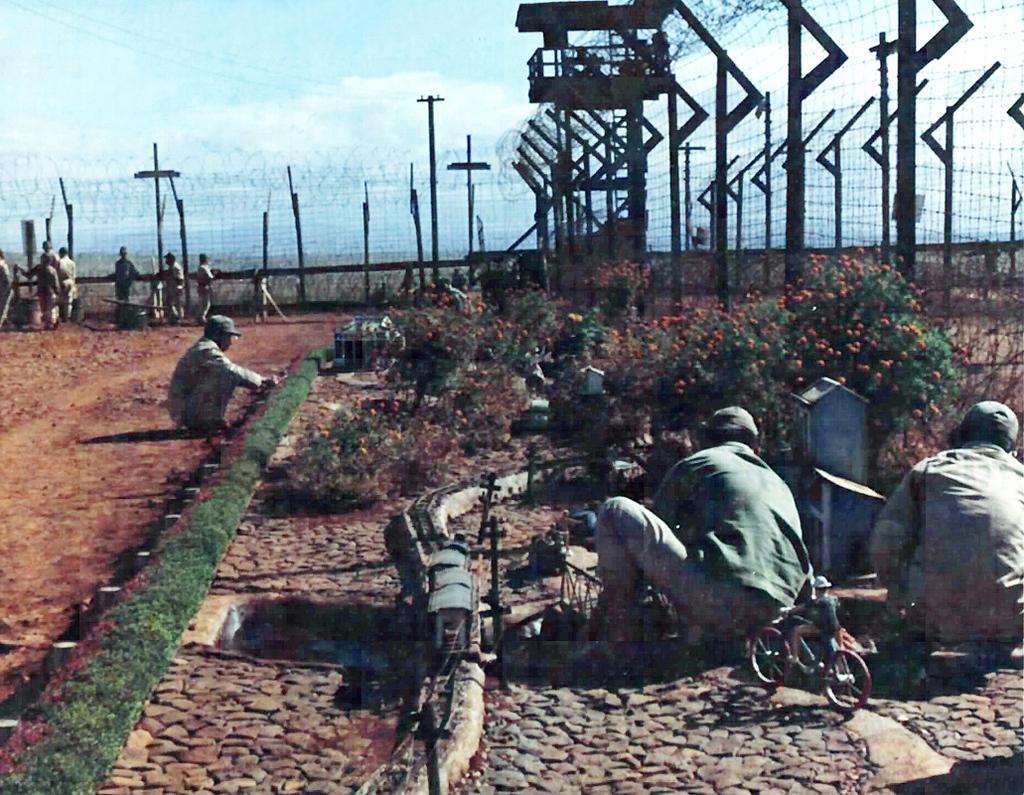Describe this image in one or two sentences. In this image I can see number of people. I can also see few are wearing caps. On the right side of the image I can see a miniature set and number of plants. In the background I can see a watchtower, number of poles, few wires, fencing, clouds and the sky. 